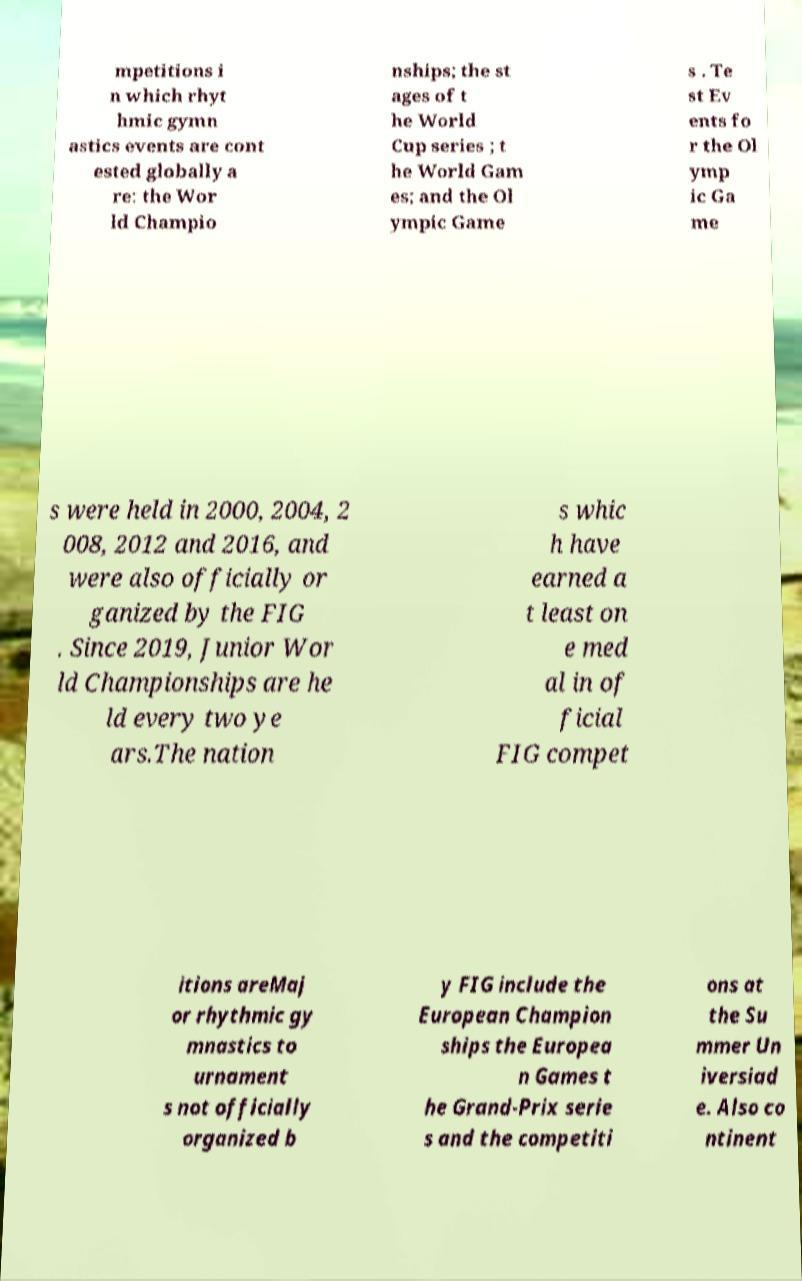Please identify and transcribe the text found in this image. mpetitions i n which rhyt hmic gymn astics events are cont ested globally a re: the Wor ld Champio nships; the st ages of t he World Cup series ; t he World Gam es; and the Ol ympic Game s . Te st Ev ents fo r the Ol ymp ic Ga me s were held in 2000, 2004, 2 008, 2012 and 2016, and were also officially or ganized by the FIG . Since 2019, Junior Wor ld Championships are he ld every two ye ars.The nation s whic h have earned a t least on e med al in of ficial FIG compet itions areMaj or rhythmic gy mnastics to urnament s not officially organized b y FIG include the European Champion ships the Europea n Games t he Grand-Prix serie s and the competiti ons at the Su mmer Un iversiad e. Also co ntinent 